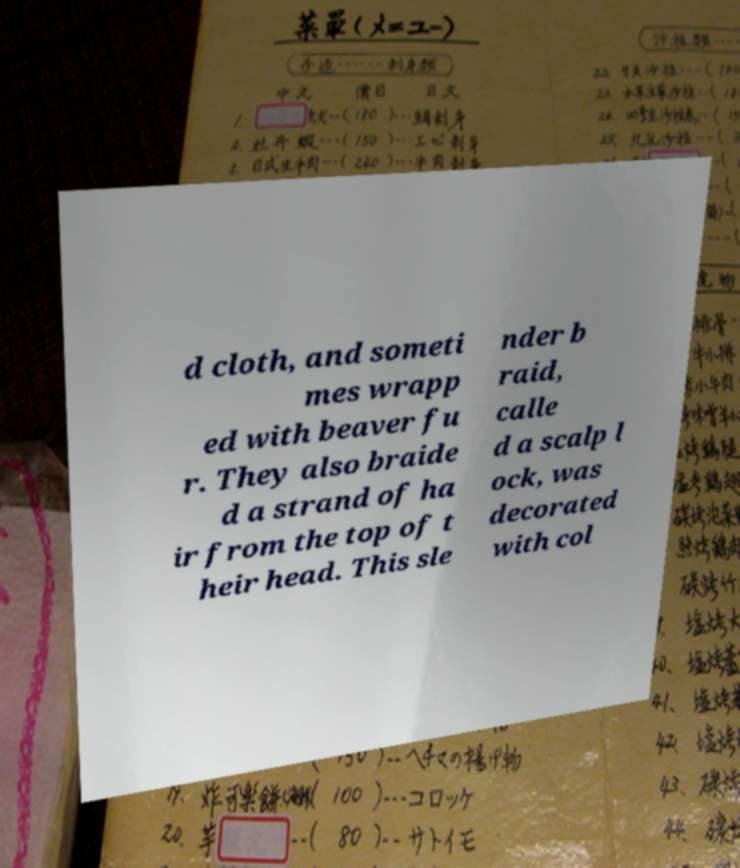I need the written content from this picture converted into text. Can you do that? d cloth, and someti mes wrapp ed with beaver fu r. They also braide d a strand of ha ir from the top of t heir head. This sle nder b raid, calle d a scalp l ock, was decorated with col 